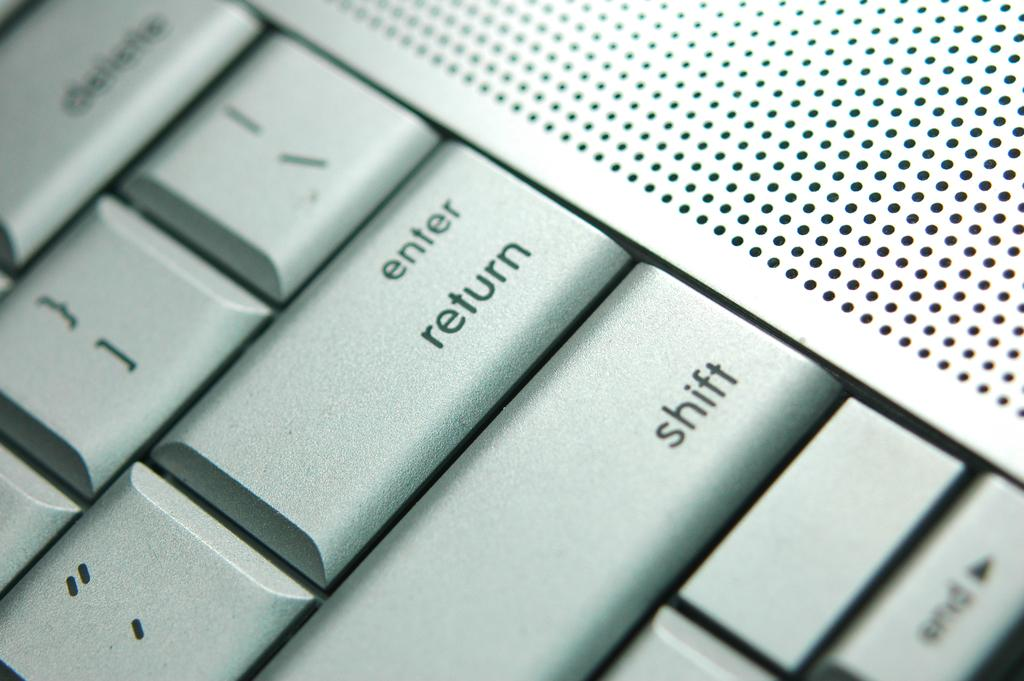<image>
Write a terse but informative summary of the picture. a closeup of a computer keyboard with enter/return and shift keys shown 